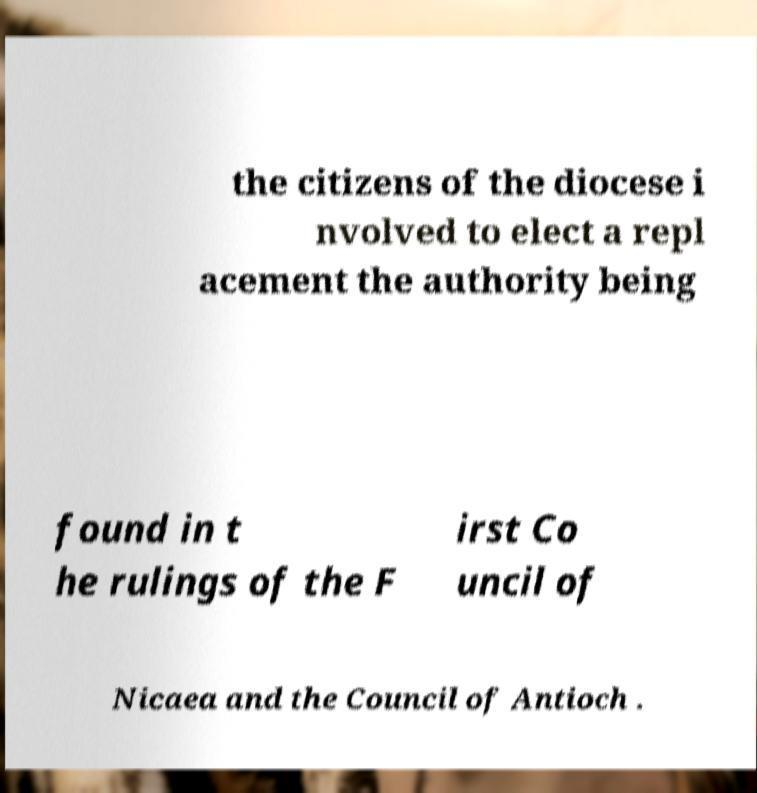I need the written content from this picture converted into text. Can you do that? the citizens of the diocese i nvolved to elect a repl acement the authority being found in t he rulings of the F irst Co uncil of Nicaea and the Council of Antioch . 